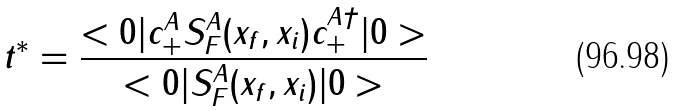Convert formula to latex. <formula><loc_0><loc_0><loc_500><loc_500>t ^ { * } = \frac { < 0 | c _ { + } ^ { A } S _ { F } ^ { A } ( x _ { f } , x _ { i } ) c _ { + } ^ { A \dagger } | 0 > } { < 0 | S _ { F } ^ { A } ( x _ { f } , x _ { i } ) | 0 > }</formula> 